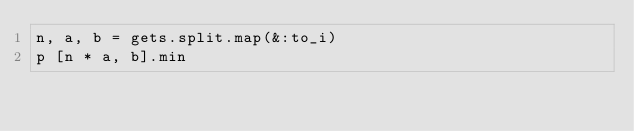<code> <loc_0><loc_0><loc_500><loc_500><_Ruby_>n, a, b = gets.split.map(&:to_i)
p [n * a, b].min</code> 